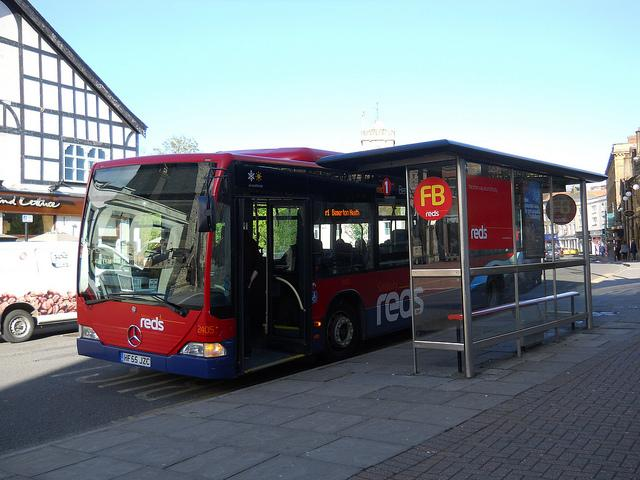What reason is the glass structure placed here? Please explain your reasoning. bus stop. It offers protection for people waiting for public transportation 